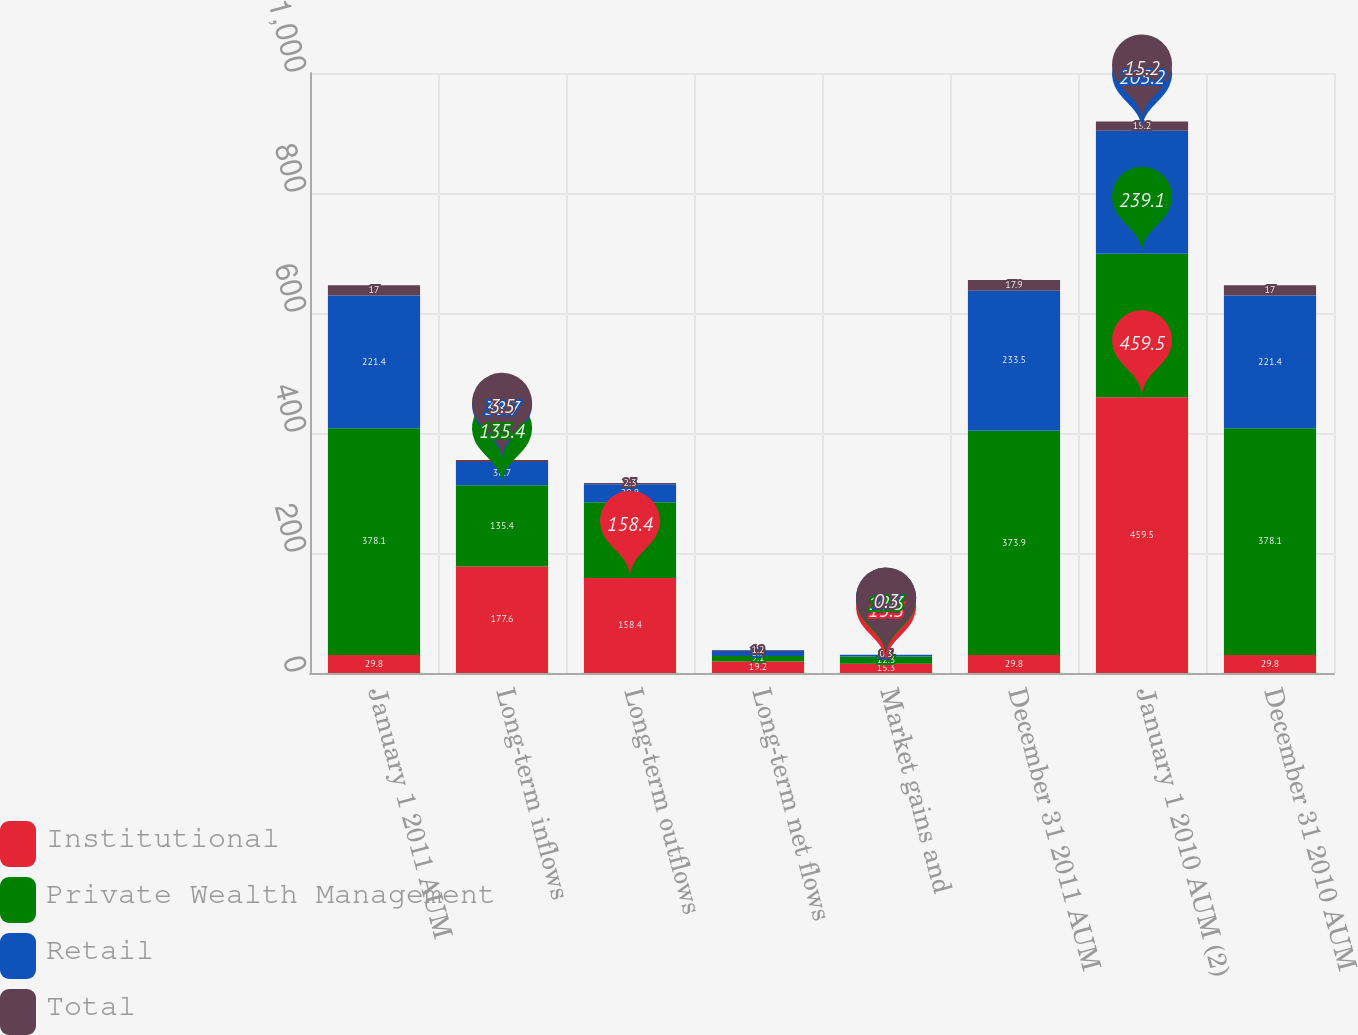Convert chart to OTSL. <chart><loc_0><loc_0><loc_500><loc_500><stacked_bar_chart><ecel><fcel>January 1 2011 AUM<fcel>Long-term inflows<fcel>Long-term outflows<fcel>Long-term net flows<fcel>Market gains and<fcel>December 31 2011 AUM<fcel>January 1 2010 AUM (2)<fcel>December 31 2010 AUM<nl><fcel>Institutional<fcel>29.8<fcel>177.6<fcel>158.4<fcel>19.2<fcel>15.3<fcel>29.8<fcel>459.5<fcel>29.8<nl><fcel>Private Wealth Management<fcel>378.1<fcel>135.4<fcel>126.3<fcel>9.1<fcel>12.3<fcel>373.9<fcel>239.1<fcel>378.1<nl><fcel>Retail<fcel>221.4<fcel>38.7<fcel>29.8<fcel>8.9<fcel>2.7<fcel>233.5<fcel>205.2<fcel>221.4<nl><fcel>Total<fcel>17<fcel>3.5<fcel>2.3<fcel>1.2<fcel>0.3<fcel>17.9<fcel>15.2<fcel>17<nl></chart> 